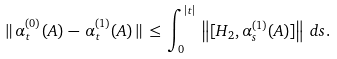<formula> <loc_0><loc_0><loc_500><loc_500>\| \, \alpha _ { t } ^ { ( 0 ) } ( A ) \, - \, \alpha _ { t } ^ { ( 1 ) } ( A ) \, \| \, \leq \, \int _ { 0 } ^ { | t | } \, \left \| [ H _ { 2 } , \alpha _ { s } ^ { ( 1 ) } ( A ) ] \right \| \, d s .</formula> 